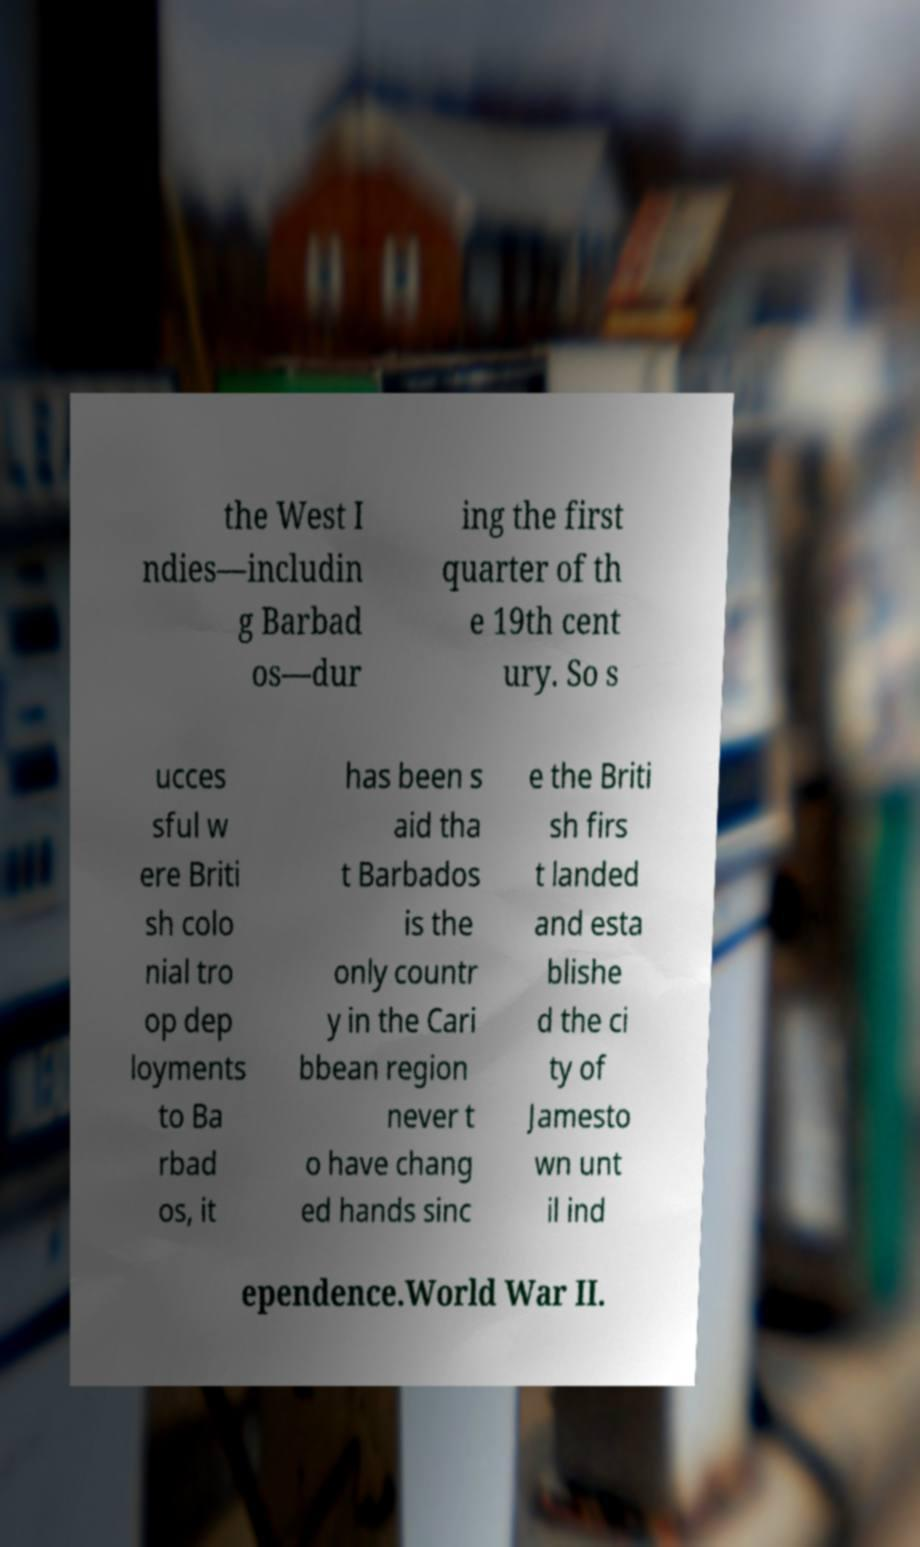Please read and relay the text visible in this image. What does it say? the West I ndies—includin g Barbad os—dur ing the first quarter of th e 19th cent ury. So s ucces sful w ere Briti sh colo nial tro op dep loyments to Ba rbad os, it has been s aid tha t Barbados is the only countr y in the Cari bbean region never t o have chang ed hands sinc e the Briti sh firs t landed and esta blishe d the ci ty of Jamesto wn unt il ind ependence.World War II. 